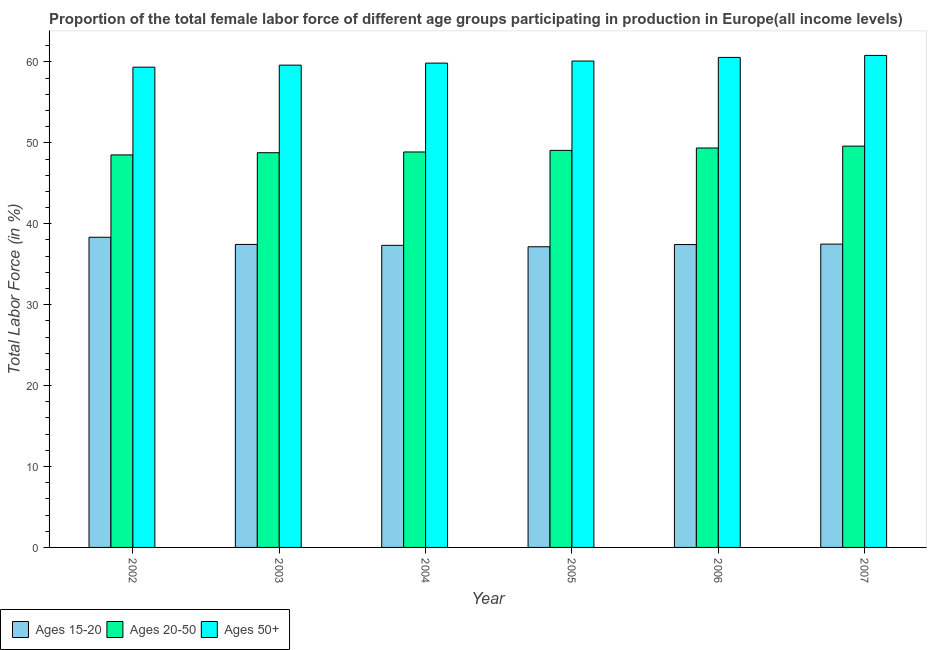Are the number of bars per tick equal to the number of legend labels?
Make the answer very short. Yes. What is the label of the 4th group of bars from the left?
Your answer should be compact. 2005. In how many cases, is the number of bars for a given year not equal to the number of legend labels?
Offer a very short reply. 0. What is the percentage of female labor force within the age group 15-20 in 2004?
Offer a terse response. 37.34. Across all years, what is the maximum percentage of female labor force above age 50?
Offer a terse response. 60.81. Across all years, what is the minimum percentage of female labor force above age 50?
Your response must be concise. 59.36. In which year was the percentage of female labor force within the age group 20-50 maximum?
Offer a very short reply. 2007. In which year was the percentage of female labor force within the age group 15-20 minimum?
Your response must be concise. 2005. What is the total percentage of female labor force within the age group 15-20 in the graph?
Ensure brevity in your answer.  225.21. What is the difference between the percentage of female labor force within the age group 15-20 in 2004 and that in 2006?
Make the answer very short. -0.09. What is the difference between the percentage of female labor force within the age group 15-20 in 2004 and the percentage of female labor force above age 50 in 2002?
Make the answer very short. -1. What is the average percentage of female labor force above age 50 per year?
Provide a short and direct response. 60.05. In the year 2005, what is the difference between the percentage of female labor force above age 50 and percentage of female labor force within the age group 20-50?
Your answer should be compact. 0. In how many years, is the percentage of female labor force within the age group 15-20 greater than 58 %?
Your response must be concise. 0. What is the ratio of the percentage of female labor force above age 50 in 2002 to that in 2007?
Provide a short and direct response. 0.98. Is the percentage of female labor force within the age group 20-50 in 2006 less than that in 2007?
Offer a very short reply. Yes. Is the difference between the percentage of female labor force within the age group 20-50 in 2004 and 2006 greater than the difference between the percentage of female labor force above age 50 in 2004 and 2006?
Offer a very short reply. No. What is the difference between the highest and the second highest percentage of female labor force above age 50?
Give a very brief answer. 0.25. What is the difference between the highest and the lowest percentage of female labor force within the age group 15-20?
Ensure brevity in your answer.  1.18. What does the 1st bar from the left in 2007 represents?
Make the answer very short. Ages 15-20. What does the 2nd bar from the right in 2004 represents?
Provide a short and direct response. Ages 20-50. Are all the bars in the graph horizontal?
Provide a short and direct response. No. Are the values on the major ticks of Y-axis written in scientific E-notation?
Provide a short and direct response. No. Does the graph contain any zero values?
Provide a succinct answer. No. Does the graph contain grids?
Make the answer very short. No. Where does the legend appear in the graph?
Your answer should be very brief. Bottom left. How many legend labels are there?
Provide a short and direct response. 3. How are the legend labels stacked?
Your answer should be very brief. Horizontal. What is the title of the graph?
Provide a succinct answer. Proportion of the total female labor force of different age groups participating in production in Europe(all income levels). Does "Agricultural raw materials" appear as one of the legend labels in the graph?
Make the answer very short. No. What is the label or title of the X-axis?
Provide a short and direct response. Year. What is the Total Labor Force (in %) of Ages 15-20 in 2002?
Make the answer very short. 38.34. What is the Total Labor Force (in %) of Ages 20-50 in 2002?
Offer a very short reply. 48.51. What is the Total Labor Force (in %) in Ages 50+ in 2002?
Ensure brevity in your answer.  59.36. What is the Total Labor Force (in %) in Ages 15-20 in 2003?
Give a very brief answer. 37.45. What is the Total Labor Force (in %) in Ages 20-50 in 2003?
Keep it short and to the point. 48.79. What is the Total Labor Force (in %) of Ages 50+ in 2003?
Offer a terse response. 59.61. What is the Total Labor Force (in %) of Ages 15-20 in 2004?
Offer a very short reply. 37.34. What is the Total Labor Force (in %) of Ages 20-50 in 2004?
Make the answer very short. 48.88. What is the Total Labor Force (in %) of Ages 50+ in 2004?
Make the answer very short. 59.86. What is the Total Labor Force (in %) in Ages 15-20 in 2005?
Give a very brief answer. 37.16. What is the Total Labor Force (in %) of Ages 20-50 in 2005?
Offer a terse response. 49.07. What is the Total Labor Force (in %) of Ages 50+ in 2005?
Your answer should be very brief. 60.12. What is the Total Labor Force (in %) of Ages 15-20 in 2006?
Provide a short and direct response. 37.43. What is the Total Labor Force (in %) of Ages 20-50 in 2006?
Give a very brief answer. 49.37. What is the Total Labor Force (in %) in Ages 50+ in 2006?
Offer a terse response. 60.56. What is the Total Labor Force (in %) in Ages 15-20 in 2007?
Keep it short and to the point. 37.49. What is the Total Labor Force (in %) of Ages 20-50 in 2007?
Make the answer very short. 49.6. What is the Total Labor Force (in %) of Ages 50+ in 2007?
Ensure brevity in your answer.  60.81. Across all years, what is the maximum Total Labor Force (in %) of Ages 15-20?
Your answer should be very brief. 38.34. Across all years, what is the maximum Total Labor Force (in %) of Ages 20-50?
Your answer should be very brief. 49.6. Across all years, what is the maximum Total Labor Force (in %) of Ages 50+?
Your answer should be compact. 60.81. Across all years, what is the minimum Total Labor Force (in %) of Ages 15-20?
Provide a succinct answer. 37.16. Across all years, what is the minimum Total Labor Force (in %) of Ages 20-50?
Keep it short and to the point. 48.51. Across all years, what is the minimum Total Labor Force (in %) of Ages 50+?
Provide a succinct answer. 59.36. What is the total Total Labor Force (in %) of Ages 15-20 in the graph?
Your answer should be compact. 225.21. What is the total Total Labor Force (in %) of Ages 20-50 in the graph?
Your answer should be very brief. 294.22. What is the total Total Labor Force (in %) of Ages 50+ in the graph?
Offer a terse response. 360.31. What is the difference between the Total Labor Force (in %) of Ages 15-20 in 2002 and that in 2003?
Give a very brief answer. 0.89. What is the difference between the Total Labor Force (in %) of Ages 20-50 in 2002 and that in 2003?
Give a very brief answer. -0.27. What is the difference between the Total Labor Force (in %) in Ages 50+ in 2002 and that in 2003?
Keep it short and to the point. -0.25. What is the difference between the Total Labor Force (in %) in Ages 20-50 in 2002 and that in 2004?
Give a very brief answer. -0.36. What is the difference between the Total Labor Force (in %) of Ages 50+ in 2002 and that in 2004?
Give a very brief answer. -0.5. What is the difference between the Total Labor Force (in %) of Ages 15-20 in 2002 and that in 2005?
Offer a very short reply. 1.18. What is the difference between the Total Labor Force (in %) of Ages 20-50 in 2002 and that in 2005?
Your response must be concise. -0.56. What is the difference between the Total Labor Force (in %) in Ages 50+ in 2002 and that in 2005?
Provide a succinct answer. -0.76. What is the difference between the Total Labor Force (in %) of Ages 15-20 in 2002 and that in 2006?
Ensure brevity in your answer.  0.9. What is the difference between the Total Labor Force (in %) of Ages 20-50 in 2002 and that in 2006?
Keep it short and to the point. -0.86. What is the difference between the Total Labor Force (in %) of Ages 50+ in 2002 and that in 2006?
Keep it short and to the point. -1.21. What is the difference between the Total Labor Force (in %) of Ages 15-20 in 2002 and that in 2007?
Provide a succinct answer. 0.85. What is the difference between the Total Labor Force (in %) of Ages 20-50 in 2002 and that in 2007?
Your response must be concise. -1.09. What is the difference between the Total Labor Force (in %) in Ages 50+ in 2002 and that in 2007?
Ensure brevity in your answer.  -1.45. What is the difference between the Total Labor Force (in %) of Ages 15-20 in 2003 and that in 2004?
Keep it short and to the point. 0.11. What is the difference between the Total Labor Force (in %) of Ages 20-50 in 2003 and that in 2004?
Provide a short and direct response. -0.09. What is the difference between the Total Labor Force (in %) in Ages 50+ in 2003 and that in 2004?
Keep it short and to the point. -0.25. What is the difference between the Total Labor Force (in %) of Ages 15-20 in 2003 and that in 2005?
Your answer should be very brief. 0.29. What is the difference between the Total Labor Force (in %) of Ages 20-50 in 2003 and that in 2005?
Offer a very short reply. -0.29. What is the difference between the Total Labor Force (in %) of Ages 50+ in 2003 and that in 2005?
Provide a short and direct response. -0.51. What is the difference between the Total Labor Force (in %) in Ages 15-20 in 2003 and that in 2006?
Keep it short and to the point. 0.02. What is the difference between the Total Labor Force (in %) of Ages 20-50 in 2003 and that in 2006?
Provide a succinct answer. -0.58. What is the difference between the Total Labor Force (in %) of Ages 50+ in 2003 and that in 2006?
Provide a succinct answer. -0.96. What is the difference between the Total Labor Force (in %) in Ages 15-20 in 2003 and that in 2007?
Make the answer very short. -0.04. What is the difference between the Total Labor Force (in %) in Ages 20-50 in 2003 and that in 2007?
Your answer should be compact. -0.82. What is the difference between the Total Labor Force (in %) in Ages 50+ in 2003 and that in 2007?
Your response must be concise. -1.2. What is the difference between the Total Labor Force (in %) of Ages 15-20 in 2004 and that in 2005?
Offer a terse response. 0.18. What is the difference between the Total Labor Force (in %) of Ages 20-50 in 2004 and that in 2005?
Make the answer very short. -0.2. What is the difference between the Total Labor Force (in %) in Ages 50+ in 2004 and that in 2005?
Your answer should be very brief. -0.26. What is the difference between the Total Labor Force (in %) in Ages 15-20 in 2004 and that in 2006?
Keep it short and to the point. -0.09. What is the difference between the Total Labor Force (in %) in Ages 20-50 in 2004 and that in 2006?
Your answer should be very brief. -0.49. What is the difference between the Total Labor Force (in %) in Ages 50+ in 2004 and that in 2006?
Offer a very short reply. -0.7. What is the difference between the Total Labor Force (in %) of Ages 15-20 in 2004 and that in 2007?
Offer a very short reply. -0.15. What is the difference between the Total Labor Force (in %) of Ages 20-50 in 2004 and that in 2007?
Keep it short and to the point. -0.72. What is the difference between the Total Labor Force (in %) of Ages 50+ in 2004 and that in 2007?
Keep it short and to the point. -0.95. What is the difference between the Total Labor Force (in %) of Ages 15-20 in 2005 and that in 2006?
Provide a succinct answer. -0.27. What is the difference between the Total Labor Force (in %) in Ages 20-50 in 2005 and that in 2006?
Offer a very short reply. -0.29. What is the difference between the Total Labor Force (in %) in Ages 50+ in 2005 and that in 2006?
Provide a succinct answer. -0.45. What is the difference between the Total Labor Force (in %) in Ages 15-20 in 2005 and that in 2007?
Give a very brief answer. -0.33. What is the difference between the Total Labor Force (in %) in Ages 20-50 in 2005 and that in 2007?
Give a very brief answer. -0.53. What is the difference between the Total Labor Force (in %) in Ages 50+ in 2005 and that in 2007?
Provide a short and direct response. -0.69. What is the difference between the Total Labor Force (in %) of Ages 15-20 in 2006 and that in 2007?
Offer a very short reply. -0.05. What is the difference between the Total Labor Force (in %) in Ages 20-50 in 2006 and that in 2007?
Provide a succinct answer. -0.23. What is the difference between the Total Labor Force (in %) in Ages 50+ in 2006 and that in 2007?
Your answer should be very brief. -0.25. What is the difference between the Total Labor Force (in %) in Ages 15-20 in 2002 and the Total Labor Force (in %) in Ages 20-50 in 2003?
Your response must be concise. -10.45. What is the difference between the Total Labor Force (in %) of Ages 15-20 in 2002 and the Total Labor Force (in %) of Ages 50+ in 2003?
Give a very brief answer. -21.27. What is the difference between the Total Labor Force (in %) of Ages 20-50 in 2002 and the Total Labor Force (in %) of Ages 50+ in 2003?
Your answer should be very brief. -11.09. What is the difference between the Total Labor Force (in %) in Ages 15-20 in 2002 and the Total Labor Force (in %) in Ages 20-50 in 2004?
Offer a terse response. -10.54. What is the difference between the Total Labor Force (in %) of Ages 15-20 in 2002 and the Total Labor Force (in %) of Ages 50+ in 2004?
Make the answer very short. -21.52. What is the difference between the Total Labor Force (in %) in Ages 20-50 in 2002 and the Total Labor Force (in %) in Ages 50+ in 2004?
Keep it short and to the point. -11.35. What is the difference between the Total Labor Force (in %) of Ages 15-20 in 2002 and the Total Labor Force (in %) of Ages 20-50 in 2005?
Your answer should be very brief. -10.74. What is the difference between the Total Labor Force (in %) in Ages 15-20 in 2002 and the Total Labor Force (in %) in Ages 50+ in 2005?
Your response must be concise. -21.78. What is the difference between the Total Labor Force (in %) in Ages 20-50 in 2002 and the Total Labor Force (in %) in Ages 50+ in 2005?
Ensure brevity in your answer.  -11.6. What is the difference between the Total Labor Force (in %) in Ages 15-20 in 2002 and the Total Labor Force (in %) in Ages 20-50 in 2006?
Your answer should be very brief. -11.03. What is the difference between the Total Labor Force (in %) in Ages 15-20 in 2002 and the Total Labor Force (in %) in Ages 50+ in 2006?
Ensure brevity in your answer.  -22.23. What is the difference between the Total Labor Force (in %) of Ages 20-50 in 2002 and the Total Labor Force (in %) of Ages 50+ in 2006?
Your answer should be compact. -12.05. What is the difference between the Total Labor Force (in %) in Ages 15-20 in 2002 and the Total Labor Force (in %) in Ages 20-50 in 2007?
Provide a succinct answer. -11.26. What is the difference between the Total Labor Force (in %) in Ages 15-20 in 2002 and the Total Labor Force (in %) in Ages 50+ in 2007?
Offer a terse response. -22.47. What is the difference between the Total Labor Force (in %) of Ages 20-50 in 2002 and the Total Labor Force (in %) of Ages 50+ in 2007?
Offer a terse response. -12.3. What is the difference between the Total Labor Force (in %) in Ages 15-20 in 2003 and the Total Labor Force (in %) in Ages 20-50 in 2004?
Keep it short and to the point. -11.43. What is the difference between the Total Labor Force (in %) of Ages 15-20 in 2003 and the Total Labor Force (in %) of Ages 50+ in 2004?
Your answer should be very brief. -22.41. What is the difference between the Total Labor Force (in %) of Ages 20-50 in 2003 and the Total Labor Force (in %) of Ages 50+ in 2004?
Provide a short and direct response. -11.07. What is the difference between the Total Labor Force (in %) in Ages 15-20 in 2003 and the Total Labor Force (in %) in Ages 20-50 in 2005?
Ensure brevity in your answer.  -11.62. What is the difference between the Total Labor Force (in %) of Ages 15-20 in 2003 and the Total Labor Force (in %) of Ages 50+ in 2005?
Ensure brevity in your answer.  -22.66. What is the difference between the Total Labor Force (in %) in Ages 20-50 in 2003 and the Total Labor Force (in %) in Ages 50+ in 2005?
Offer a terse response. -11.33. What is the difference between the Total Labor Force (in %) in Ages 15-20 in 2003 and the Total Labor Force (in %) in Ages 20-50 in 2006?
Make the answer very short. -11.92. What is the difference between the Total Labor Force (in %) in Ages 15-20 in 2003 and the Total Labor Force (in %) in Ages 50+ in 2006?
Give a very brief answer. -23.11. What is the difference between the Total Labor Force (in %) of Ages 20-50 in 2003 and the Total Labor Force (in %) of Ages 50+ in 2006?
Provide a succinct answer. -11.78. What is the difference between the Total Labor Force (in %) of Ages 15-20 in 2003 and the Total Labor Force (in %) of Ages 20-50 in 2007?
Offer a very short reply. -12.15. What is the difference between the Total Labor Force (in %) in Ages 15-20 in 2003 and the Total Labor Force (in %) in Ages 50+ in 2007?
Offer a very short reply. -23.36. What is the difference between the Total Labor Force (in %) in Ages 20-50 in 2003 and the Total Labor Force (in %) in Ages 50+ in 2007?
Provide a succinct answer. -12.02. What is the difference between the Total Labor Force (in %) in Ages 15-20 in 2004 and the Total Labor Force (in %) in Ages 20-50 in 2005?
Your response must be concise. -11.74. What is the difference between the Total Labor Force (in %) in Ages 15-20 in 2004 and the Total Labor Force (in %) in Ages 50+ in 2005?
Ensure brevity in your answer.  -22.78. What is the difference between the Total Labor Force (in %) of Ages 20-50 in 2004 and the Total Labor Force (in %) of Ages 50+ in 2005?
Offer a very short reply. -11.24. What is the difference between the Total Labor Force (in %) in Ages 15-20 in 2004 and the Total Labor Force (in %) in Ages 20-50 in 2006?
Your response must be concise. -12.03. What is the difference between the Total Labor Force (in %) of Ages 15-20 in 2004 and the Total Labor Force (in %) of Ages 50+ in 2006?
Your answer should be compact. -23.23. What is the difference between the Total Labor Force (in %) of Ages 20-50 in 2004 and the Total Labor Force (in %) of Ages 50+ in 2006?
Provide a short and direct response. -11.69. What is the difference between the Total Labor Force (in %) of Ages 15-20 in 2004 and the Total Labor Force (in %) of Ages 20-50 in 2007?
Offer a terse response. -12.26. What is the difference between the Total Labor Force (in %) of Ages 15-20 in 2004 and the Total Labor Force (in %) of Ages 50+ in 2007?
Your answer should be compact. -23.47. What is the difference between the Total Labor Force (in %) of Ages 20-50 in 2004 and the Total Labor Force (in %) of Ages 50+ in 2007?
Provide a short and direct response. -11.93. What is the difference between the Total Labor Force (in %) of Ages 15-20 in 2005 and the Total Labor Force (in %) of Ages 20-50 in 2006?
Your response must be concise. -12.21. What is the difference between the Total Labor Force (in %) of Ages 15-20 in 2005 and the Total Labor Force (in %) of Ages 50+ in 2006?
Offer a very short reply. -23.4. What is the difference between the Total Labor Force (in %) in Ages 20-50 in 2005 and the Total Labor Force (in %) in Ages 50+ in 2006?
Your answer should be very brief. -11.49. What is the difference between the Total Labor Force (in %) in Ages 15-20 in 2005 and the Total Labor Force (in %) in Ages 20-50 in 2007?
Provide a short and direct response. -12.44. What is the difference between the Total Labor Force (in %) of Ages 15-20 in 2005 and the Total Labor Force (in %) of Ages 50+ in 2007?
Your response must be concise. -23.65. What is the difference between the Total Labor Force (in %) of Ages 20-50 in 2005 and the Total Labor Force (in %) of Ages 50+ in 2007?
Make the answer very short. -11.74. What is the difference between the Total Labor Force (in %) in Ages 15-20 in 2006 and the Total Labor Force (in %) in Ages 20-50 in 2007?
Offer a very short reply. -12.17. What is the difference between the Total Labor Force (in %) in Ages 15-20 in 2006 and the Total Labor Force (in %) in Ages 50+ in 2007?
Your response must be concise. -23.38. What is the difference between the Total Labor Force (in %) of Ages 20-50 in 2006 and the Total Labor Force (in %) of Ages 50+ in 2007?
Your response must be concise. -11.44. What is the average Total Labor Force (in %) in Ages 15-20 per year?
Ensure brevity in your answer.  37.53. What is the average Total Labor Force (in %) of Ages 20-50 per year?
Your answer should be compact. 49.04. What is the average Total Labor Force (in %) of Ages 50+ per year?
Provide a short and direct response. 60.05. In the year 2002, what is the difference between the Total Labor Force (in %) in Ages 15-20 and Total Labor Force (in %) in Ages 20-50?
Your answer should be very brief. -10.18. In the year 2002, what is the difference between the Total Labor Force (in %) in Ages 15-20 and Total Labor Force (in %) in Ages 50+?
Offer a very short reply. -21.02. In the year 2002, what is the difference between the Total Labor Force (in %) of Ages 20-50 and Total Labor Force (in %) of Ages 50+?
Your answer should be compact. -10.84. In the year 2003, what is the difference between the Total Labor Force (in %) of Ages 15-20 and Total Labor Force (in %) of Ages 20-50?
Offer a terse response. -11.34. In the year 2003, what is the difference between the Total Labor Force (in %) in Ages 15-20 and Total Labor Force (in %) in Ages 50+?
Your answer should be compact. -22.16. In the year 2003, what is the difference between the Total Labor Force (in %) in Ages 20-50 and Total Labor Force (in %) in Ages 50+?
Your answer should be very brief. -10.82. In the year 2004, what is the difference between the Total Labor Force (in %) in Ages 15-20 and Total Labor Force (in %) in Ages 20-50?
Keep it short and to the point. -11.54. In the year 2004, what is the difference between the Total Labor Force (in %) of Ages 15-20 and Total Labor Force (in %) of Ages 50+?
Offer a very short reply. -22.52. In the year 2004, what is the difference between the Total Labor Force (in %) in Ages 20-50 and Total Labor Force (in %) in Ages 50+?
Provide a succinct answer. -10.98. In the year 2005, what is the difference between the Total Labor Force (in %) of Ages 15-20 and Total Labor Force (in %) of Ages 20-50?
Your answer should be compact. -11.91. In the year 2005, what is the difference between the Total Labor Force (in %) in Ages 15-20 and Total Labor Force (in %) in Ages 50+?
Keep it short and to the point. -22.95. In the year 2005, what is the difference between the Total Labor Force (in %) of Ages 20-50 and Total Labor Force (in %) of Ages 50+?
Make the answer very short. -11.04. In the year 2006, what is the difference between the Total Labor Force (in %) of Ages 15-20 and Total Labor Force (in %) of Ages 20-50?
Keep it short and to the point. -11.94. In the year 2006, what is the difference between the Total Labor Force (in %) in Ages 15-20 and Total Labor Force (in %) in Ages 50+?
Give a very brief answer. -23.13. In the year 2006, what is the difference between the Total Labor Force (in %) of Ages 20-50 and Total Labor Force (in %) of Ages 50+?
Give a very brief answer. -11.19. In the year 2007, what is the difference between the Total Labor Force (in %) in Ages 15-20 and Total Labor Force (in %) in Ages 20-50?
Your response must be concise. -12.11. In the year 2007, what is the difference between the Total Labor Force (in %) of Ages 15-20 and Total Labor Force (in %) of Ages 50+?
Your response must be concise. -23.32. In the year 2007, what is the difference between the Total Labor Force (in %) of Ages 20-50 and Total Labor Force (in %) of Ages 50+?
Your answer should be compact. -11.21. What is the ratio of the Total Labor Force (in %) in Ages 15-20 in 2002 to that in 2003?
Your answer should be compact. 1.02. What is the ratio of the Total Labor Force (in %) in Ages 20-50 in 2002 to that in 2003?
Offer a terse response. 0.99. What is the ratio of the Total Labor Force (in %) in Ages 15-20 in 2002 to that in 2004?
Make the answer very short. 1.03. What is the ratio of the Total Labor Force (in %) of Ages 50+ in 2002 to that in 2004?
Offer a very short reply. 0.99. What is the ratio of the Total Labor Force (in %) in Ages 15-20 in 2002 to that in 2005?
Your answer should be very brief. 1.03. What is the ratio of the Total Labor Force (in %) in Ages 20-50 in 2002 to that in 2005?
Offer a very short reply. 0.99. What is the ratio of the Total Labor Force (in %) of Ages 50+ in 2002 to that in 2005?
Your response must be concise. 0.99. What is the ratio of the Total Labor Force (in %) of Ages 15-20 in 2002 to that in 2006?
Keep it short and to the point. 1.02. What is the ratio of the Total Labor Force (in %) of Ages 20-50 in 2002 to that in 2006?
Your response must be concise. 0.98. What is the ratio of the Total Labor Force (in %) in Ages 50+ in 2002 to that in 2006?
Your answer should be compact. 0.98. What is the ratio of the Total Labor Force (in %) in Ages 15-20 in 2002 to that in 2007?
Provide a succinct answer. 1.02. What is the ratio of the Total Labor Force (in %) in Ages 20-50 in 2002 to that in 2007?
Your answer should be compact. 0.98. What is the ratio of the Total Labor Force (in %) of Ages 50+ in 2002 to that in 2007?
Your response must be concise. 0.98. What is the ratio of the Total Labor Force (in %) in Ages 20-50 in 2003 to that in 2004?
Ensure brevity in your answer.  1. What is the ratio of the Total Labor Force (in %) in Ages 50+ in 2003 to that in 2004?
Provide a succinct answer. 1. What is the ratio of the Total Labor Force (in %) in Ages 15-20 in 2003 to that in 2005?
Provide a succinct answer. 1.01. What is the ratio of the Total Labor Force (in %) in Ages 20-50 in 2003 to that in 2005?
Your response must be concise. 0.99. What is the ratio of the Total Labor Force (in %) of Ages 50+ in 2003 to that in 2005?
Ensure brevity in your answer.  0.99. What is the ratio of the Total Labor Force (in %) of Ages 15-20 in 2003 to that in 2006?
Your answer should be compact. 1. What is the ratio of the Total Labor Force (in %) in Ages 50+ in 2003 to that in 2006?
Offer a terse response. 0.98. What is the ratio of the Total Labor Force (in %) of Ages 20-50 in 2003 to that in 2007?
Provide a succinct answer. 0.98. What is the ratio of the Total Labor Force (in %) in Ages 50+ in 2003 to that in 2007?
Offer a very short reply. 0.98. What is the ratio of the Total Labor Force (in %) in Ages 50+ in 2004 to that in 2006?
Your answer should be very brief. 0.99. What is the ratio of the Total Labor Force (in %) in Ages 20-50 in 2004 to that in 2007?
Your answer should be very brief. 0.99. What is the ratio of the Total Labor Force (in %) in Ages 50+ in 2004 to that in 2007?
Provide a short and direct response. 0.98. What is the ratio of the Total Labor Force (in %) in Ages 15-20 in 2005 to that in 2006?
Provide a succinct answer. 0.99. What is the ratio of the Total Labor Force (in %) in Ages 15-20 in 2005 to that in 2007?
Ensure brevity in your answer.  0.99. What is the ratio of the Total Labor Force (in %) in Ages 20-50 in 2005 to that in 2007?
Provide a short and direct response. 0.99. What is the ratio of the Total Labor Force (in %) of Ages 50+ in 2005 to that in 2007?
Your response must be concise. 0.99. What is the ratio of the Total Labor Force (in %) in Ages 15-20 in 2006 to that in 2007?
Offer a very short reply. 1. What is the difference between the highest and the second highest Total Labor Force (in %) of Ages 15-20?
Provide a short and direct response. 0.85. What is the difference between the highest and the second highest Total Labor Force (in %) in Ages 20-50?
Provide a succinct answer. 0.23. What is the difference between the highest and the second highest Total Labor Force (in %) of Ages 50+?
Make the answer very short. 0.25. What is the difference between the highest and the lowest Total Labor Force (in %) of Ages 15-20?
Ensure brevity in your answer.  1.18. What is the difference between the highest and the lowest Total Labor Force (in %) in Ages 20-50?
Offer a terse response. 1.09. What is the difference between the highest and the lowest Total Labor Force (in %) of Ages 50+?
Offer a terse response. 1.45. 